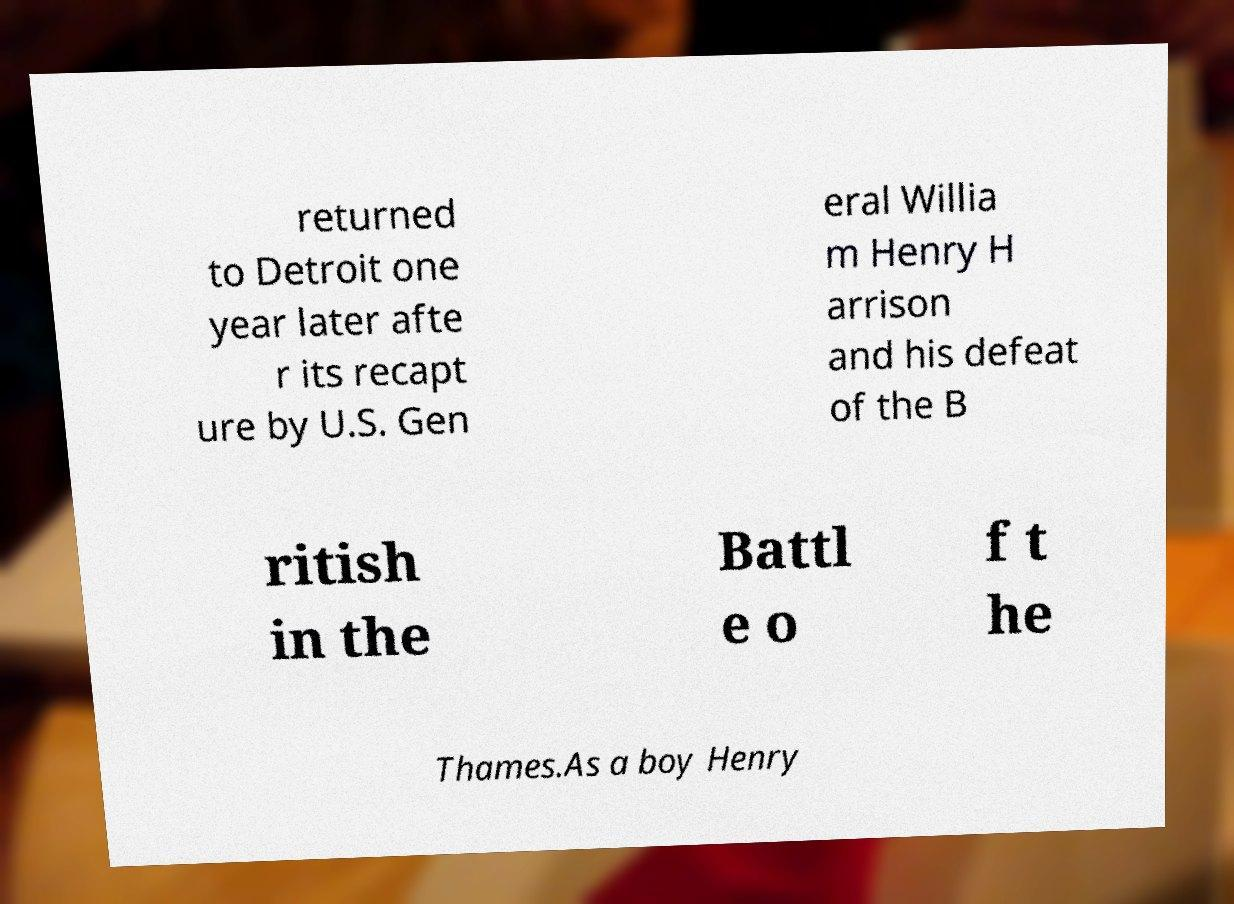Please identify and transcribe the text found in this image. returned to Detroit one year later afte r its recapt ure by U.S. Gen eral Willia m Henry H arrison and his defeat of the B ritish in the Battl e o f t he Thames.As a boy Henry 